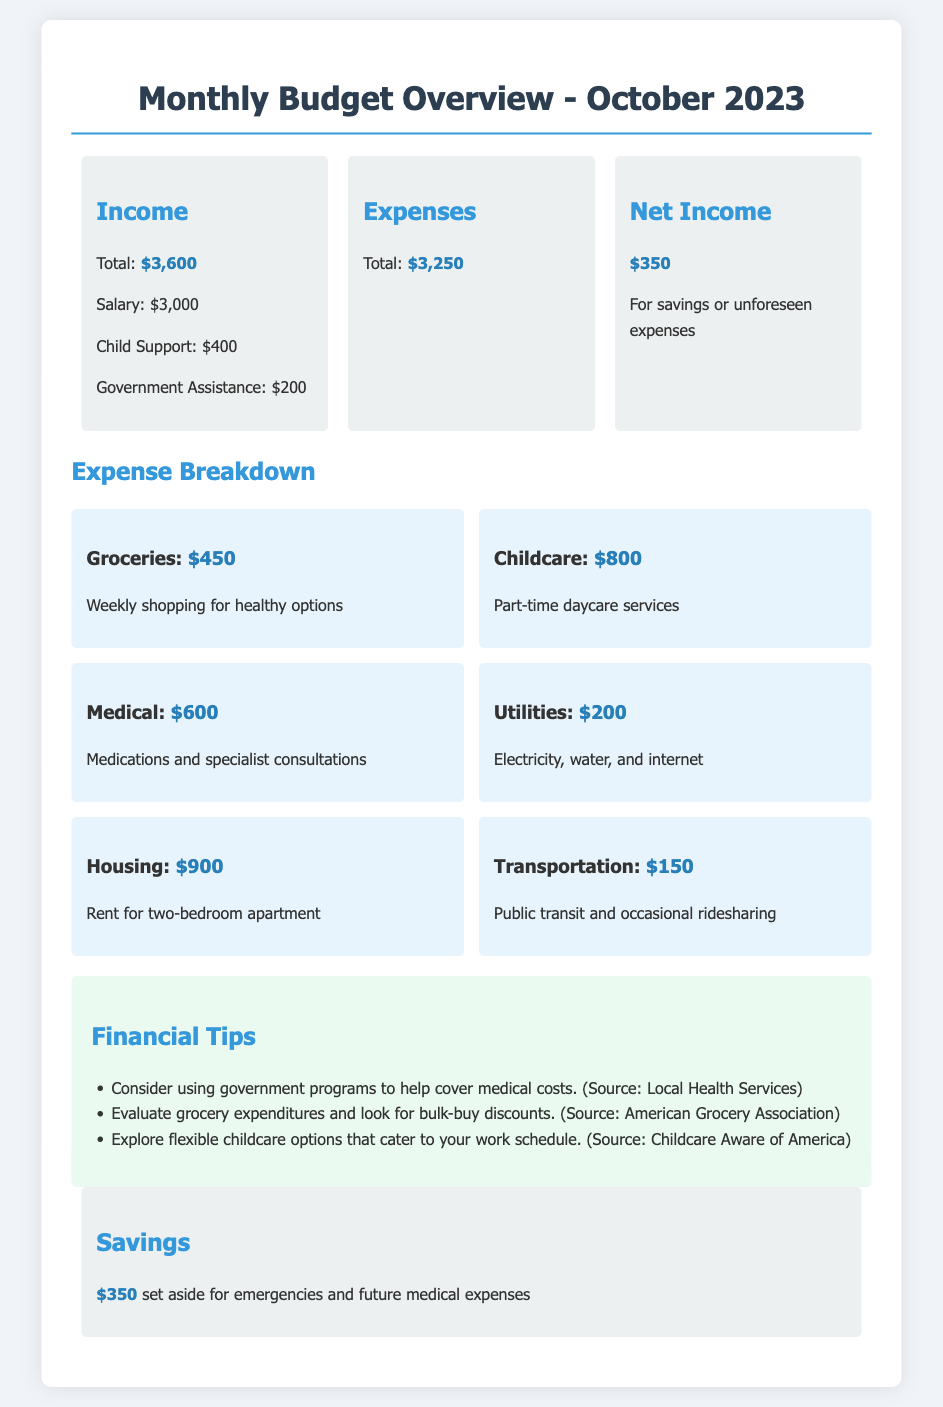What is the total income? The total income is the sum of salary, child support, and government assistance, which is $3000 + $400 + $200 = $3600.
Answer: $3,600 What is the total amount spent on groceries? The document states that $450 was spent on groceries during the month.
Answer: $450 What is the amount allocated for medical expenses? The specific amount spent on medical expenses as mentioned in the document is $600.
Answer: $600 What is the net income? Net income is calculated by subtracting total expenses from total income, which is $3600 - $3250 = $350.
Answer: $350 What is the total amount spent on childcare? According to the document, $800 was spent on childcare services.
Answer: $800 How much was spent on housing? The report indicates expenditures of $900 on housing for the month.
Answer: $900 What financial tip suggests evaluating grocery expenditures? The tip advises looking for bulk-buy discounts to save on grocery expenditures.
Answer: Evaluate grocery expenditures How much is set aside for emergencies and future medical expenses? The document specifies that $350 has been set aside for emergencies and future medical expenses.
Answer: $350 What percentage of the total income was allocated to medical expenses? To find the percentage, divide the medical expenses ($600) by total income ($3600) and multiply by 100, giving approximately 16.67%.
Answer: Approximately 16.67% 